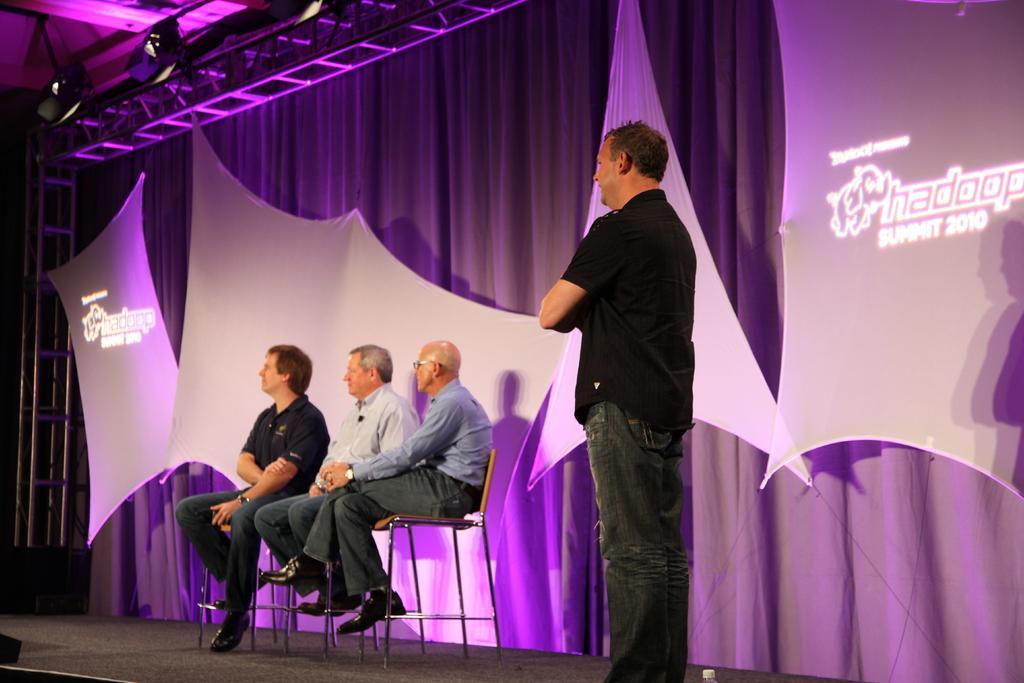Can you describe this image briefly? In this picture we can see few people are sitting on a chairs, side one person is standing, behind we can see cloth and some boards. 